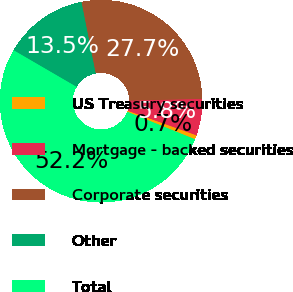Convert chart. <chart><loc_0><loc_0><loc_500><loc_500><pie_chart><fcel>US Treasury securities<fcel>Mortgage - backed securities<fcel>Corporate securities<fcel>Other<fcel>Total<nl><fcel>0.68%<fcel>5.83%<fcel>27.75%<fcel>13.5%<fcel>52.25%<nl></chart> 